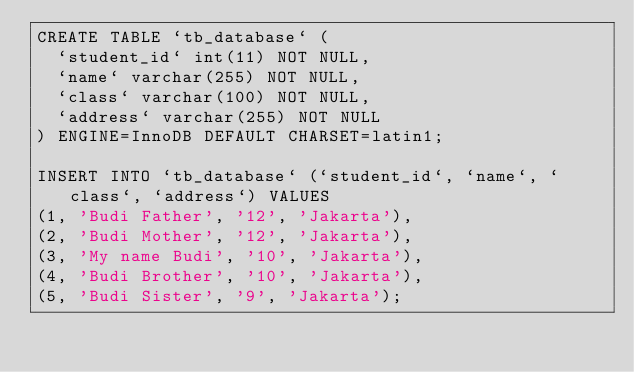Convert code to text. <code><loc_0><loc_0><loc_500><loc_500><_SQL_>CREATE TABLE `tb_database` (
  `student_id` int(11) NOT NULL,
  `name` varchar(255) NOT NULL,
  `class` varchar(100) NOT NULL,
  `address` varchar(255) NOT NULL
) ENGINE=InnoDB DEFAULT CHARSET=latin1;

INSERT INTO `tb_database` (`student_id`, `name`, `class`, `address`) VALUES
(1, 'Budi Father', '12', 'Jakarta'),
(2, 'Budi Mother', '12', 'Jakarta'),
(3, 'My name Budi', '10', 'Jakarta'),
(4, 'Budi Brother', '10', 'Jakarta'),
(5, 'Budi Sister', '9', 'Jakarta');</code> 